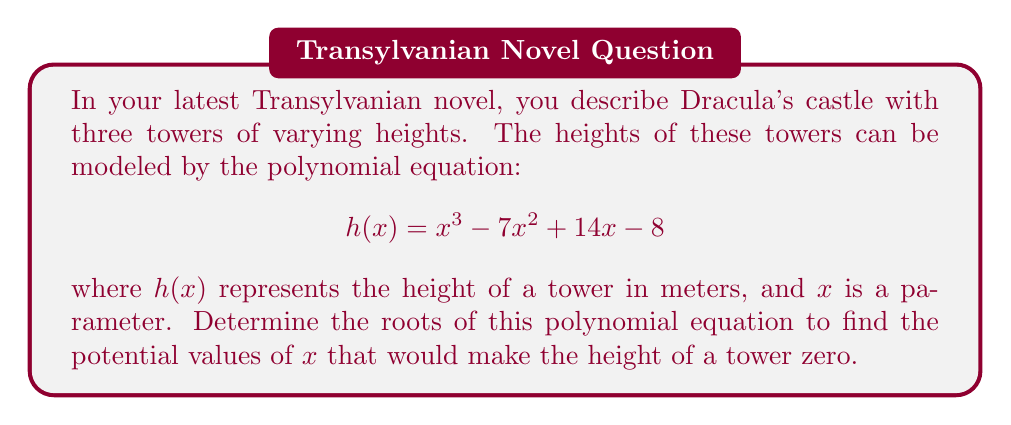Give your solution to this math problem. To find the roots of the polynomial equation, we need to solve:

$$x^3 - 7x^2 + 14x - 8 = 0$$

We can use the rational root theorem to find potential rational roots. The potential rational roots are the factors of the constant term (8): ±1, ±2, ±4, ±8.

Let's test these values:

1) $h(1) = 1^3 - 7(1)^2 + 14(1) - 8 = 1 - 7 + 14 - 8 = 0$

We found one root: $x = 1$. Now we can factor out $(x-1)$:

$$(x-1)(x^2 - 6x + 8) = 0$$

We can solve the quadratic equation $x^2 - 6x + 8 = 0$ using the quadratic formula:

$$x = \frac{-b \pm \sqrt{b^2 - 4ac}}{2a}$$

Where $a=1$, $b=-6$, and $c=8$

$$x = \frac{6 \pm \sqrt{36 - 32}}{2} = \frac{6 \pm \sqrt{4}}{2} = \frac{6 \pm 2}{2}$$

This gives us two more roots:

$$x = \frac{6 + 2}{2} = 4$$ and $$x = \frac{6 - 2}{2} = 2$$

Therefore, the three roots of the polynomial equation are 1, 2, and 4.
Answer: The roots of the polynomial equation are $x = 1$, $x = 2$, and $x = 4$. 